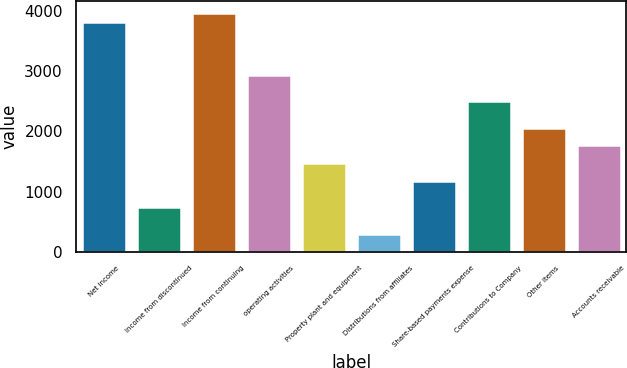Convert chart. <chart><loc_0><loc_0><loc_500><loc_500><bar_chart><fcel>Net income<fcel>Income from discontinued<fcel>Income from continuing<fcel>operating activities<fcel>Property plant and equipment<fcel>Distributions from affiliates<fcel>Share-based payments expense<fcel>Contributions to Company<fcel>Other items<fcel>Accounts receivable<nl><fcel>3824.7<fcel>737.7<fcel>3971.7<fcel>2942.7<fcel>1472.7<fcel>296.7<fcel>1178.7<fcel>2501.7<fcel>2060.7<fcel>1766.7<nl></chart> 